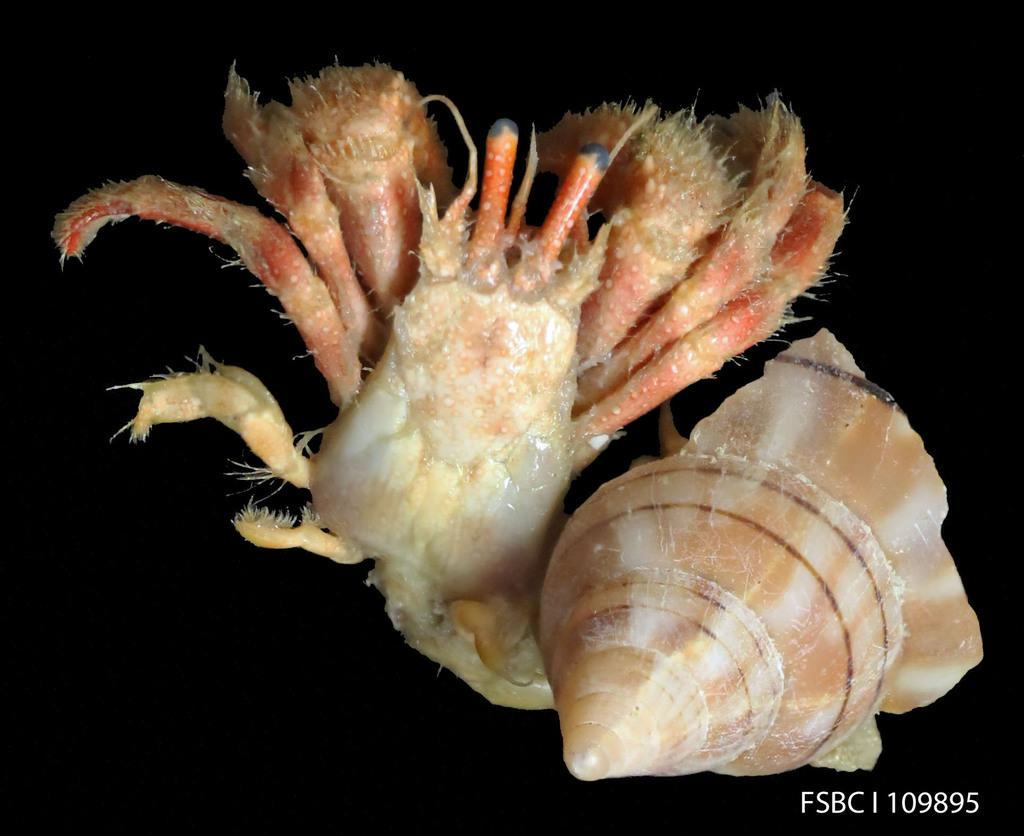What is the main object in the image? There is a sea shell in the image. What else can be seen in the image besides the sea shell? There is an animal in the image. How would you describe the overall appearance of the image? The background of the image is dark. Where is the text located in the image? The text is written on the image, located at the bottom on the right side. What type of mitten is being used by the animal in the image? There is no mitten present in the image; the animal is not wearing any clothing. 